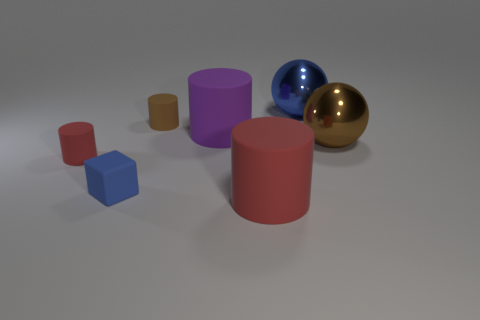What materials appear to be represented by the objects in this composition? The objects in the image seem to depict various materials. Starting from the left, the small block looks like rubber, given its matte texture. The small cylinder and the cube possess slightly reflective surfaces which could indicate they are made of plastic. The larger, matte cylinder behind might be made of ceramic or a painted metal due to its lack of shine. Finally, the two spheres on the right appear to be metallic, likely steel or aluminum, as one is blue and shiny, while the larger one bears a reflective gold finish. 